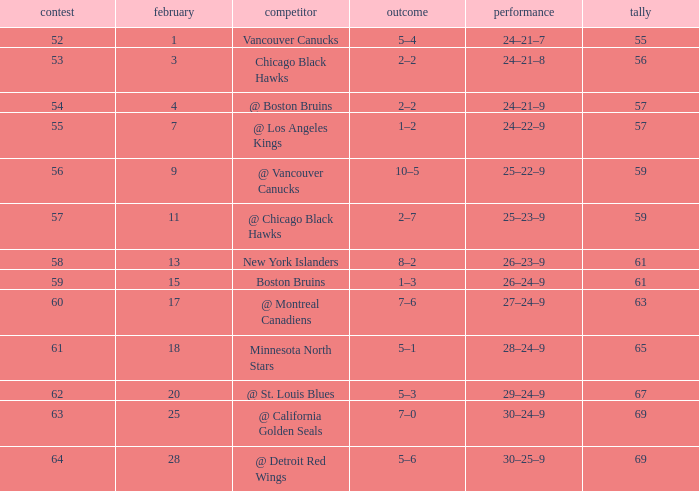How many games have a record of 30–25–9 and more points than 69? 0.0. 